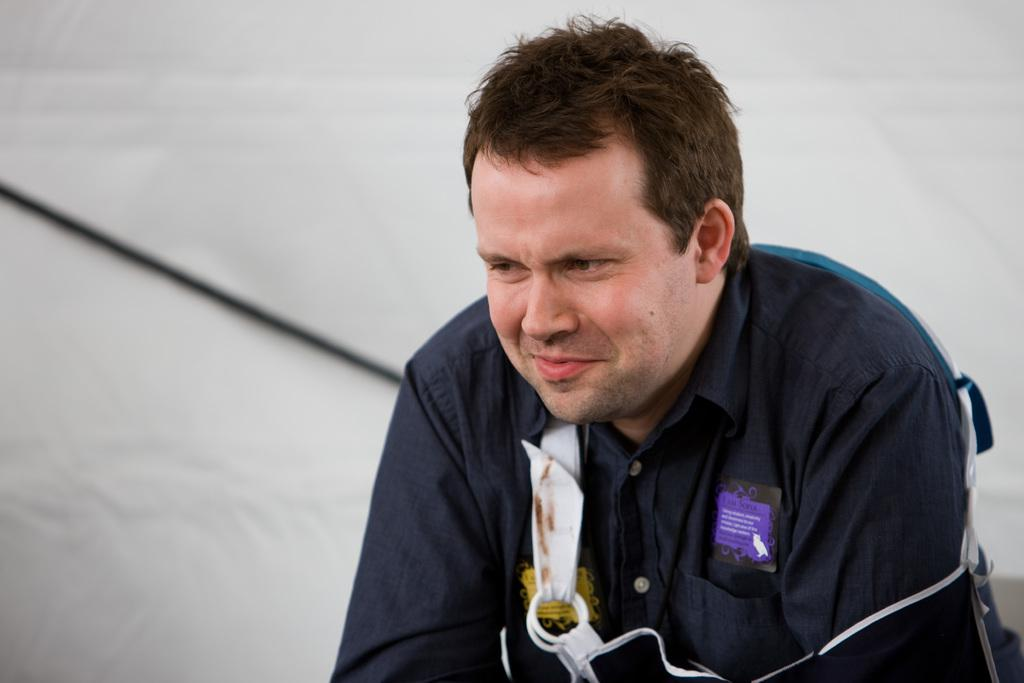What is the main subject of the image? There is a person in the image. What is the person's facial expression? The person is smiling. What color is the background of the image? The background of the image is white. How many apples can be seen in the image? There are no apples present in the image. What letters are visible on the person's shirt in the image? There is no information about the person's shirt or any letters on it in the provided facts. 